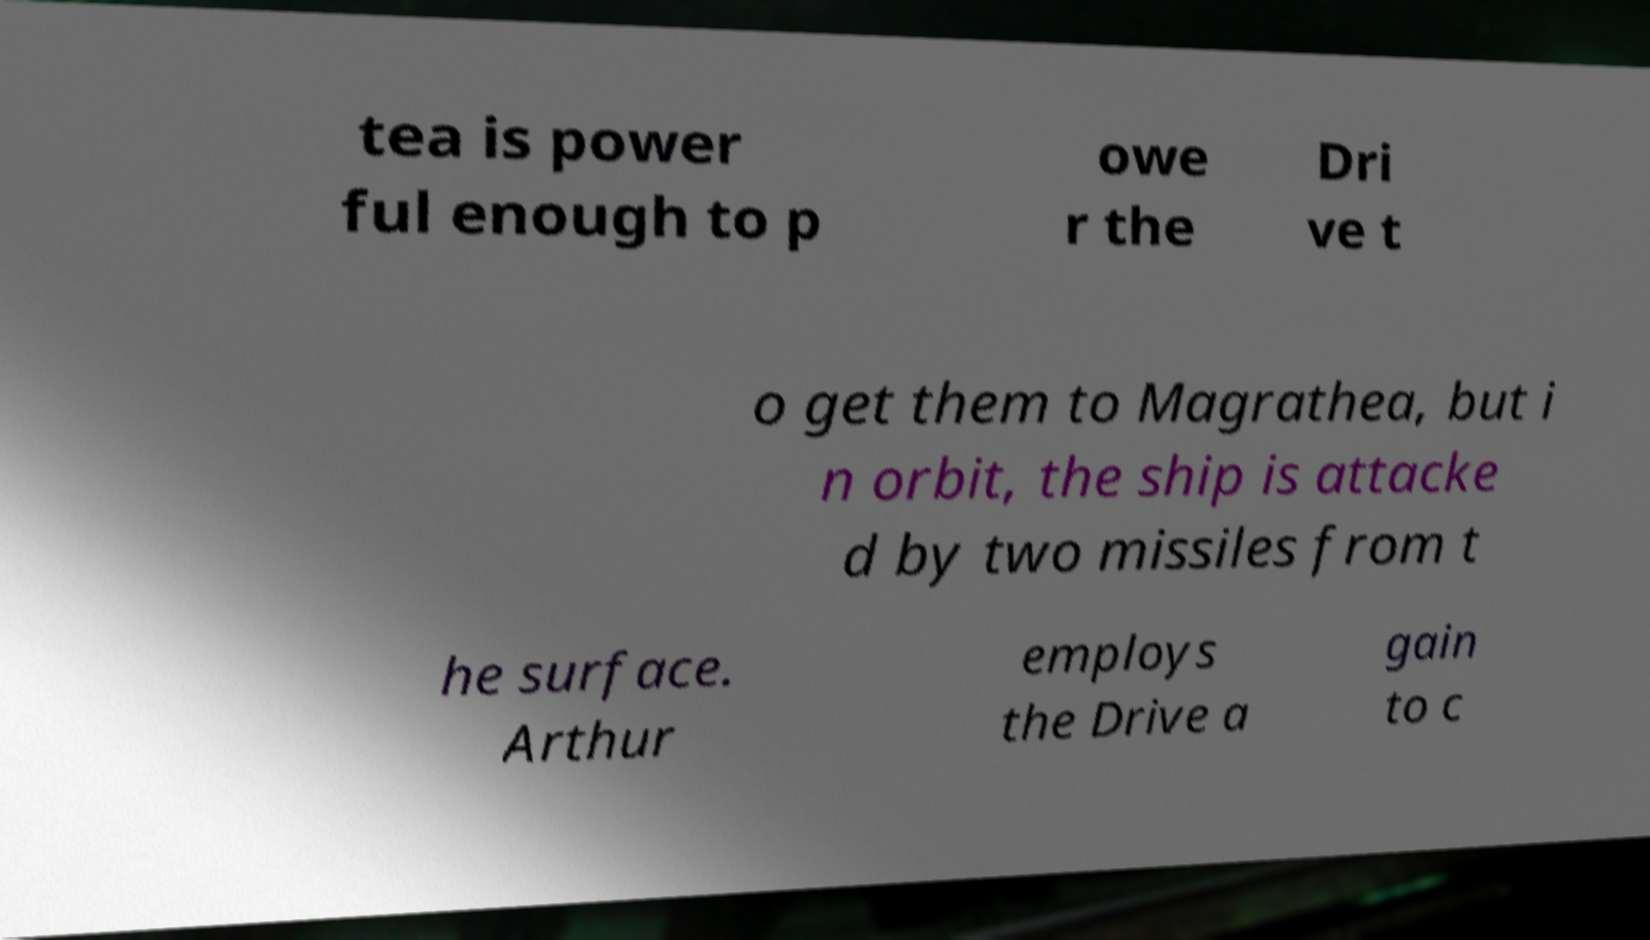I need the written content from this picture converted into text. Can you do that? tea is power ful enough to p owe r the Dri ve t o get them to Magrathea, but i n orbit, the ship is attacke d by two missiles from t he surface. Arthur employs the Drive a gain to c 